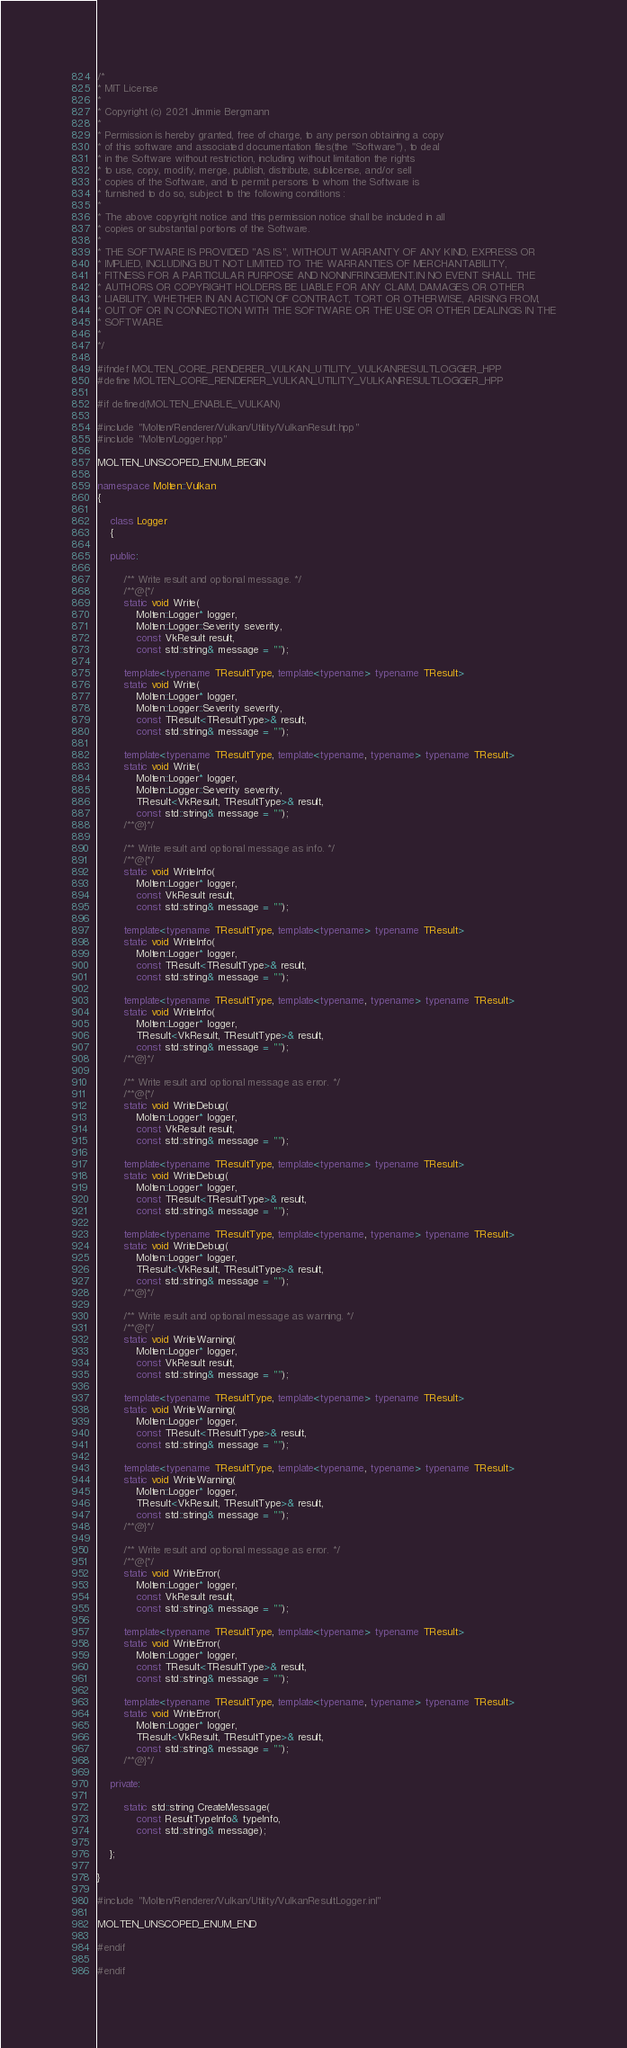<code> <loc_0><loc_0><loc_500><loc_500><_C++_>/*
* MIT License
*
* Copyright (c) 2021 Jimmie Bergmann
*
* Permission is hereby granted, free of charge, to any person obtaining a copy
* of this software and associated documentation files(the "Software"), to deal
* in the Software without restriction, including without limitation the rights
* to use, copy, modify, merge, publish, distribute, sublicense, and/or sell
* copies of the Software, and to permit persons to whom the Software is
* furnished to do so, subject to the following conditions :
*
* The above copyright notice and this permission notice shall be included in all
* copies or substantial portions of the Software.
*
* THE SOFTWARE IS PROVIDED "AS IS", WITHOUT WARRANTY OF ANY KIND, EXPRESS OR
* IMPLIED, INCLUDING BUT NOT LIMITED TO THE WARRANTIES OF MERCHANTABILITY,
* FITNESS FOR A PARTICULAR PURPOSE AND NONINFRINGEMENT.IN NO EVENT SHALL THE
* AUTHORS OR COPYRIGHT HOLDERS BE LIABLE FOR ANY CLAIM, DAMAGES OR OTHER
* LIABILITY, WHETHER IN AN ACTION OF CONTRACT, TORT OR OTHERWISE, ARISING FROM,
* OUT OF OR IN CONNECTION WITH THE SOFTWARE OR THE USE OR OTHER DEALINGS IN THE
* SOFTWARE.
*
*/

#ifndef MOLTEN_CORE_RENDERER_VULKAN_UTILITY_VULKANRESULTLOGGER_HPP
#define MOLTEN_CORE_RENDERER_VULKAN_UTILITY_VULKANRESULTLOGGER_HPP

#if defined(MOLTEN_ENABLE_VULKAN)

#include "Molten/Renderer/Vulkan/Utility/VulkanResult.hpp"
#include "Molten/Logger.hpp"

MOLTEN_UNSCOPED_ENUM_BEGIN

namespace Molten::Vulkan
{

    class Logger
    {

    public:

        /** Write result and optional message. */
        /**@{*/
        static void Write(
            Molten::Logger* logger,
            Molten::Logger::Severity severity,
            const VkResult result,
            const std::string& message = "");

        template<typename TResultType, template<typename> typename TResult>
        static void Write(
            Molten::Logger* logger,
            Molten::Logger::Severity severity,
            const TResult<TResultType>& result,
            const std::string& message = "");

        template<typename TResultType, template<typename, typename> typename TResult>
        static void Write(
            Molten::Logger* logger,
            Molten::Logger::Severity severity,
            TResult<VkResult, TResultType>& result,
            const std::string& message = "");
        /**@}*/

        /** Write result and optional message as info. */
        /**@{*/
        static void WriteInfo(
            Molten::Logger* logger,
            const VkResult result,
            const std::string& message = "");

        template<typename TResultType, template<typename> typename TResult>
        static void WriteInfo(
            Molten::Logger* logger,
            const TResult<TResultType>& result,
            const std::string& message = "");

        template<typename TResultType, template<typename, typename> typename TResult>
        static void WriteInfo(
            Molten::Logger* logger,
            TResult<VkResult, TResultType>& result,
            const std::string& message = "");
        /**@}*/

        /** Write result and optional message as error. */
        /**@{*/
        static void WriteDebug(
            Molten::Logger* logger,
            const VkResult result,
            const std::string& message = "");

        template<typename TResultType, template<typename> typename TResult>
        static void WriteDebug(
            Molten::Logger* logger,
            const TResult<TResultType>& result,
            const std::string& message = "");

        template<typename TResultType, template<typename, typename> typename TResult>
        static void WriteDebug(
            Molten::Logger* logger,
            TResult<VkResult, TResultType>& result,
            const std::string& message = "");
        /**@}*/

        /** Write result and optional message as warning. */
        /**@{*/
        static void WriteWarning(
            Molten::Logger* logger,
            const VkResult result,
            const std::string& message = "");

        template<typename TResultType, template<typename> typename TResult>
        static void WriteWarning(
            Molten::Logger* logger,
            const TResult<TResultType>& result,
            const std::string& message = "");

        template<typename TResultType, template<typename, typename> typename TResult>
        static void WriteWarning(
            Molten::Logger* logger,
            TResult<VkResult, TResultType>& result,
            const std::string& message = "");
        /**@}*/

        /** Write result and optional message as error. */
        /**@{*/
        static void WriteError(
            Molten::Logger* logger,
            const VkResult result,
            const std::string& message = "");

        template<typename TResultType, template<typename> typename TResult>
        static void WriteError(
            Molten::Logger* logger,
            const TResult<TResultType>& result,
            const std::string& message = "");

        template<typename TResultType, template<typename, typename> typename TResult>
        static void WriteError(
            Molten::Logger* logger,
            TResult<VkResult, TResultType>& result,
            const std::string& message = "");
        /**@}*/

    private:

        static std::string CreateMessage(
            const ResultTypeInfo& typeInfo,
            const std::string& message);

    };

}

#include "Molten/Renderer/Vulkan/Utility/VulkanResultLogger.inl"

MOLTEN_UNSCOPED_ENUM_END

#endif

#endif</code> 